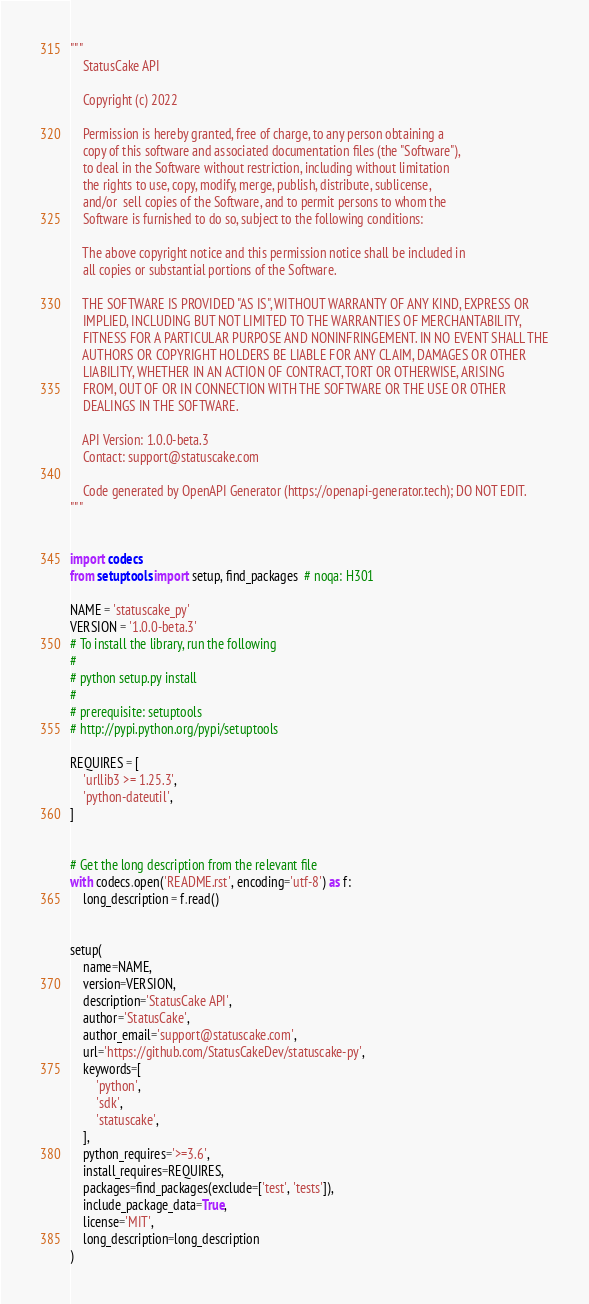Convert code to text. <code><loc_0><loc_0><loc_500><loc_500><_Python_>"""
    StatusCake API

    Copyright (c) 2022

    Permission is hereby granted, free of charge, to any person obtaining a
    copy of this software and associated documentation files (the "Software"),
    to deal in the Software without restriction, including without limitation
    the rights to use, copy, modify, merge, publish, distribute, sublicense,
    and/or  sell copies of the Software, and to permit persons to whom the
    Software is furnished to do so, subject to the following conditions:

    The above copyright notice and this permission notice shall be included in
    all copies or substantial portions of the Software.

    THE SOFTWARE IS PROVIDED "AS IS", WITHOUT WARRANTY OF ANY KIND, EXPRESS OR
    IMPLIED, INCLUDING BUT NOT LIMITED TO THE WARRANTIES OF MERCHANTABILITY,
    FITNESS FOR A PARTICULAR PURPOSE AND NONINFRINGEMENT. IN NO EVENT SHALL THE
    AUTHORS OR COPYRIGHT HOLDERS BE LIABLE FOR ANY CLAIM, DAMAGES OR OTHER
    LIABILITY, WHETHER IN AN ACTION OF CONTRACT, TORT OR OTHERWISE, ARISING
    FROM, OUT OF OR IN CONNECTION WITH THE SOFTWARE OR THE USE OR OTHER
    DEALINGS IN THE SOFTWARE.

    API Version: 1.0.0-beta.3
    Contact: support@statuscake.com

    Code generated by OpenAPI Generator (https://openapi-generator.tech); DO NOT EDIT.
"""


import codecs
from setuptools import setup, find_packages  # noqa: H301

NAME = 'statuscake_py'
VERSION = '1.0.0-beta.3'
# To install the library, run the following
#
# python setup.py install
#
# prerequisite: setuptools
# http://pypi.python.org/pypi/setuptools

REQUIRES = [
    'urllib3 >= 1.25.3',
    'python-dateutil',
]


# Get the long description from the relevant file
with codecs.open('README.rst', encoding='utf-8') as f:
    long_description = f.read()


setup(
    name=NAME,
    version=VERSION,
    description='StatusCake API',
    author='StatusCake',
    author_email='support@statuscake.com',
    url='https://github.com/StatusCakeDev/statuscake-py',
    keywords=[
        'python',
        'sdk',
        'statuscake',
    ],
    python_requires='>=3.6',
    install_requires=REQUIRES,
    packages=find_packages(exclude=['test', 'tests']),
    include_package_data=True,
    license='MIT',
    long_description=long_description
)
</code> 